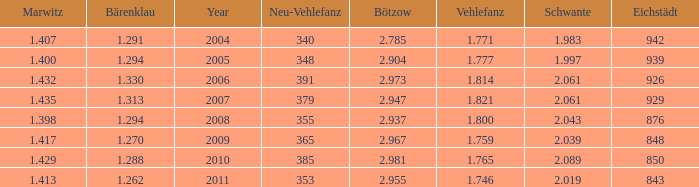What year has a Schwante smaller than 2.043, an Eichstädt smaller than 848, and a Bärenklau smaller than 1.262? 0.0. 